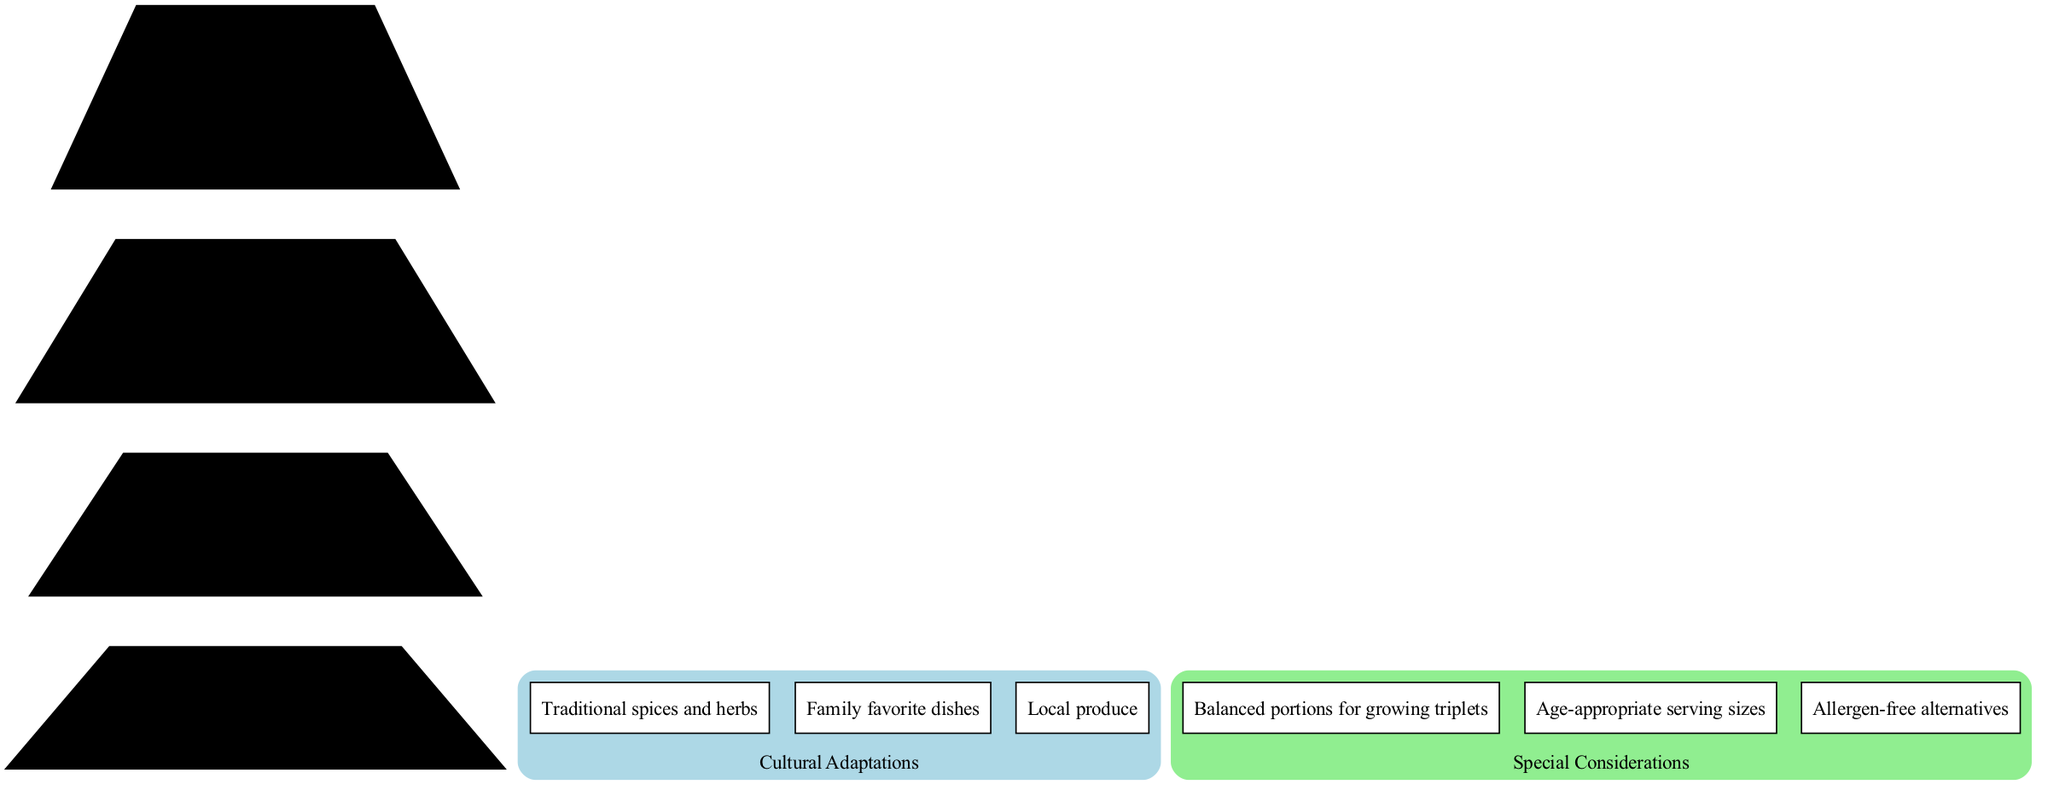What items are listed in the "Sparingly" level? The "Sparingly" level lists items that should be consumed infrequently. By examining the diagram, the items at this level are directly presented, which are "Sweets," "Oils," and "Processed snacks."
Answer: Sweets, Oils, Processed snacks How many levels are there in the pyramid? The pyramid consists of several levels, which can be counted directly within the diagram. There are four distinct levels shown in the pyramid.
Answer: 4 What is the foundation of the pyramid? The foundation level of the pyramid typically signifies the most essential items for a balanced diet. Upon reviewing the diagram, the foundation items listed are "Water" and "Physical activity."
Answer: Water, Physical activity Which cultural adaptations are included in the diagram? The diagram includes a section for cultural adaptations. By checking this section, the cultural adaptations mentioned are "Traditional spices and herbs," "Family favorite dishes," and "Local produce."
Answer: Traditional spices and herbs, Family favorite dishes, Local produce Why is it important to consider age-appropriate serving sizes? The diagram emphasizes the significance of tailored considerations for triplets, where each child requires specific nutritional needs. Age-appropriate serving sizes are vital to ensure that each triplet receives the correct amount of nutrients for their growth and development.
Answer: For growth and development What items fall under the "Moderately" level? The "Moderately" level lists foods that should be consumed in moderate amounts, and through careful inspection of the diagram, it can be determined that this level includes "Lean meats," "Fish," "Eggs," and "Dairy."
Answer: Lean meats, Fish, Eggs, Dairy How are the levels connected in the pyramid? The connectivity of the pyramid levels is represented by edges connecting each one to the next, indicating the hierarchical relationship. The first level is the highest, and each lower level emphasizes the foundation of a balanced diet, which flows down towards "Water" and "Physical activity."
Answer: Hierarchically connected What special considerations are made for the triplets? The diagram indicates specific considerations necessary for the dietary structure for triplets. These include "Balanced portions for growing triplets," "Age-appropriate serving sizes," and "Allergen-free alternatives," which are essential for their health.
Answer: Balanced portions, Age-appropriate sizes, Allergen-free alternatives 